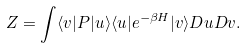Convert formula to latex. <formula><loc_0><loc_0><loc_500><loc_500>Z = \int \langle v | P | u \rangle \langle u | e ^ { - { \beta H } } | v \rangle D u D v .</formula> 